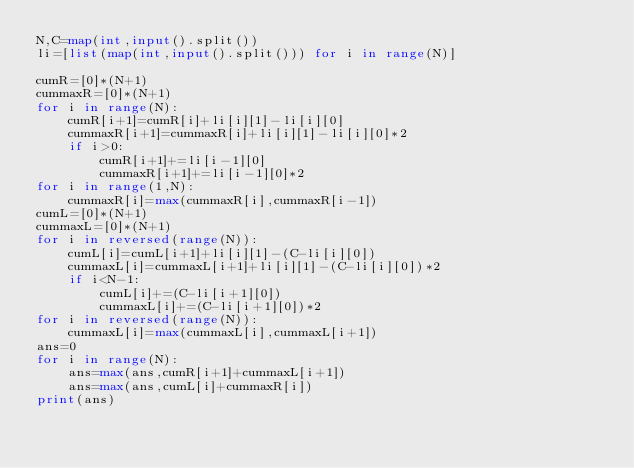Convert code to text. <code><loc_0><loc_0><loc_500><loc_500><_Python_>N,C=map(int,input().split())
li=[list(map(int,input().split())) for i in range(N)]

cumR=[0]*(N+1)
cummaxR=[0]*(N+1)
for i in range(N):
    cumR[i+1]=cumR[i]+li[i][1]-li[i][0]
    cummaxR[i+1]=cummaxR[i]+li[i][1]-li[i][0]*2
    if i>0:
        cumR[i+1]+=li[i-1][0]
        cummaxR[i+1]+=li[i-1][0]*2
for i in range(1,N):
    cummaxR[i]=max(cummaxR[i],cummaxR[i-1])
cumL=[0]*(N+1)
cummaxL=[0]*(N+1)
for i in reversed(range(N)):
    cumL[i]=cumL[i+1]+li[i][1]-(C-li[i][0])
    cummaxL[i]=cummaxL[i+1]+li[i][1]-(C-li[i][0])*2
    if i<N-1:
        cumL[i]+=(C-li[i+1][0])
        cummaxL[i]+=(C-li[i+1][0])*2
for i in reversed(range(N)):
    cummaxL[i]=max(cummaxL[i],cummaxL[i+1])
ans=0
for i in range(N):
    ans=max(ans,cumR[i+1]+cummaxL[i+1])
    ans=max(ans,cumL[i]+cummaxR[i])
print(ans)</code> 